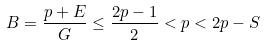<formula> <loc_0><loc_0><loc_500><loc_500>B = \frac { p + E } { G } \leq \frac { 2 p - 1 } { 2 } < p < 2 p - S</formula> 